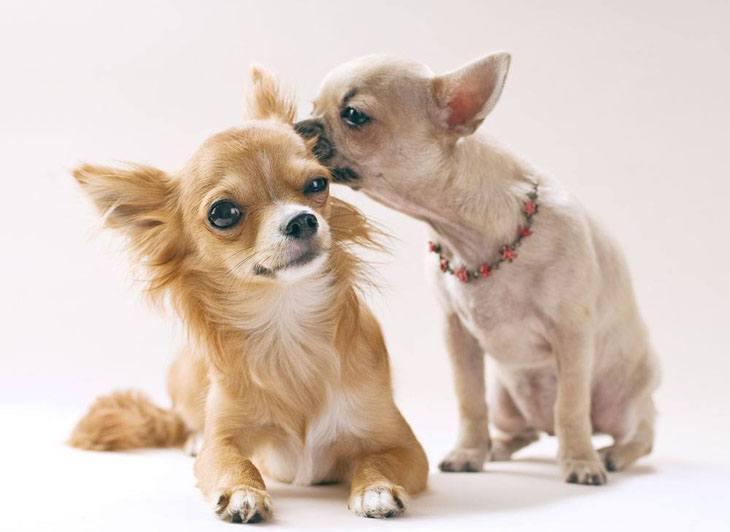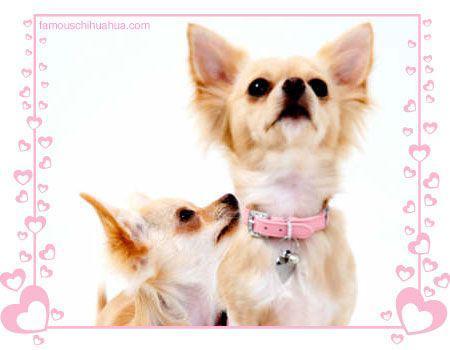The first image is the image on the left, the second image is the image on the right. Assess this claim about the two images: "An image includes two dogs, both in some type of container that features a polka-dotted pinkish element.". Correct or not? Answer yes or no. No. The first image is the image on the left, the second image is the image on the right. Considering the images on both sides, is "One image shows exactly two dogs with each dog in its own separate container or placemat; no two dogs share a spot." valid? Answer yes or no. No. 